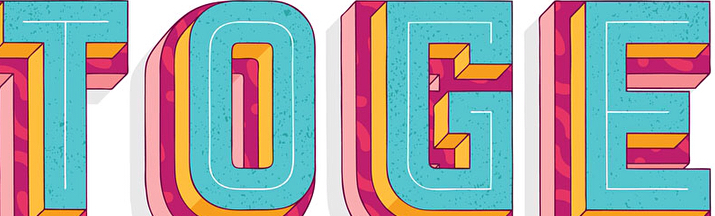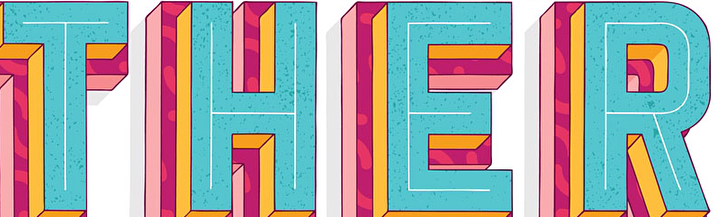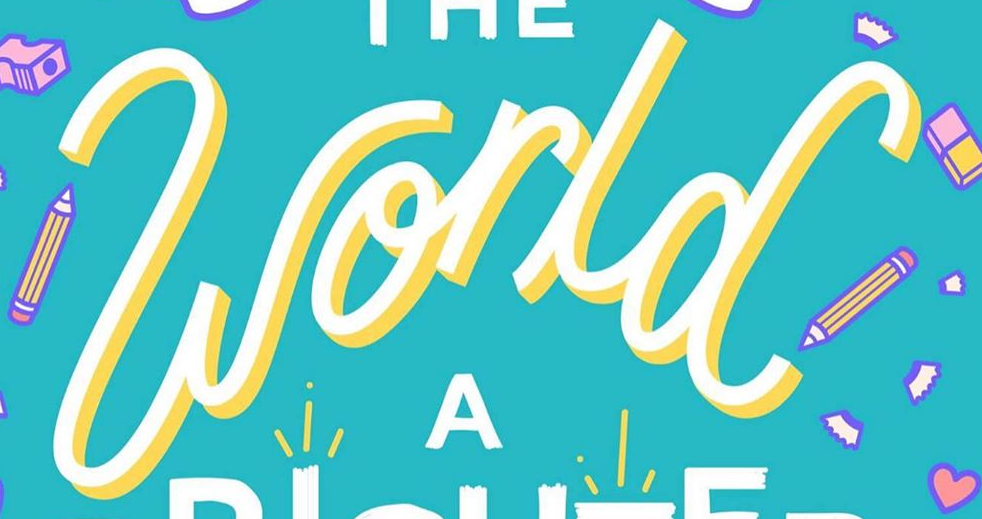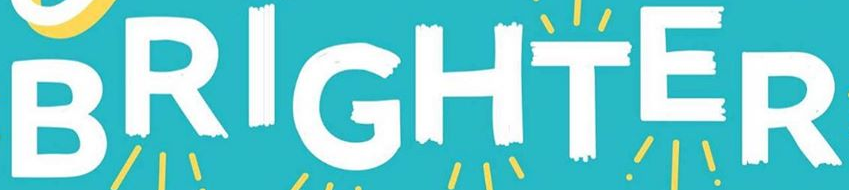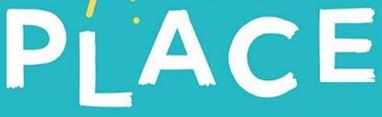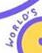What text is displayed in these images sequentially, separated by a semicolon? TOGE; THER; world; BRIGHTER; PLACE; WORLO'S 